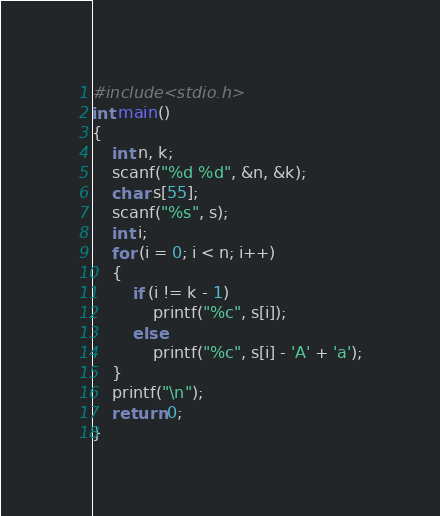Convert code to text. <code><loc_0><loc_0><loc_500><loc_500><_C_>#include<stdio.h>
int main()
{
	int n, k;
	scanf("%d %d", &n, &k);
	char s[55];
	scanf("%s", s);
	int i;
	for (i = 0; i < n; i++)
	{
		if (i != k - 1)
			printf("%c", s[i]);
		else
			printf("%c", s[i] - 'A' + 'a');
	}
	printf("\n");
	return 0;
}</code> 